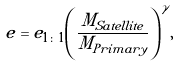Convert formula to latex. <formula><loc_0><loc_0><loc_500><loc_500>e = e _ { 1 \colon 1 } { \left ( \frac { M _ { S a t e l l i t e } } { M _ { P r i m a r y } } \right ) } ^ { \gamma } ,</formula> 